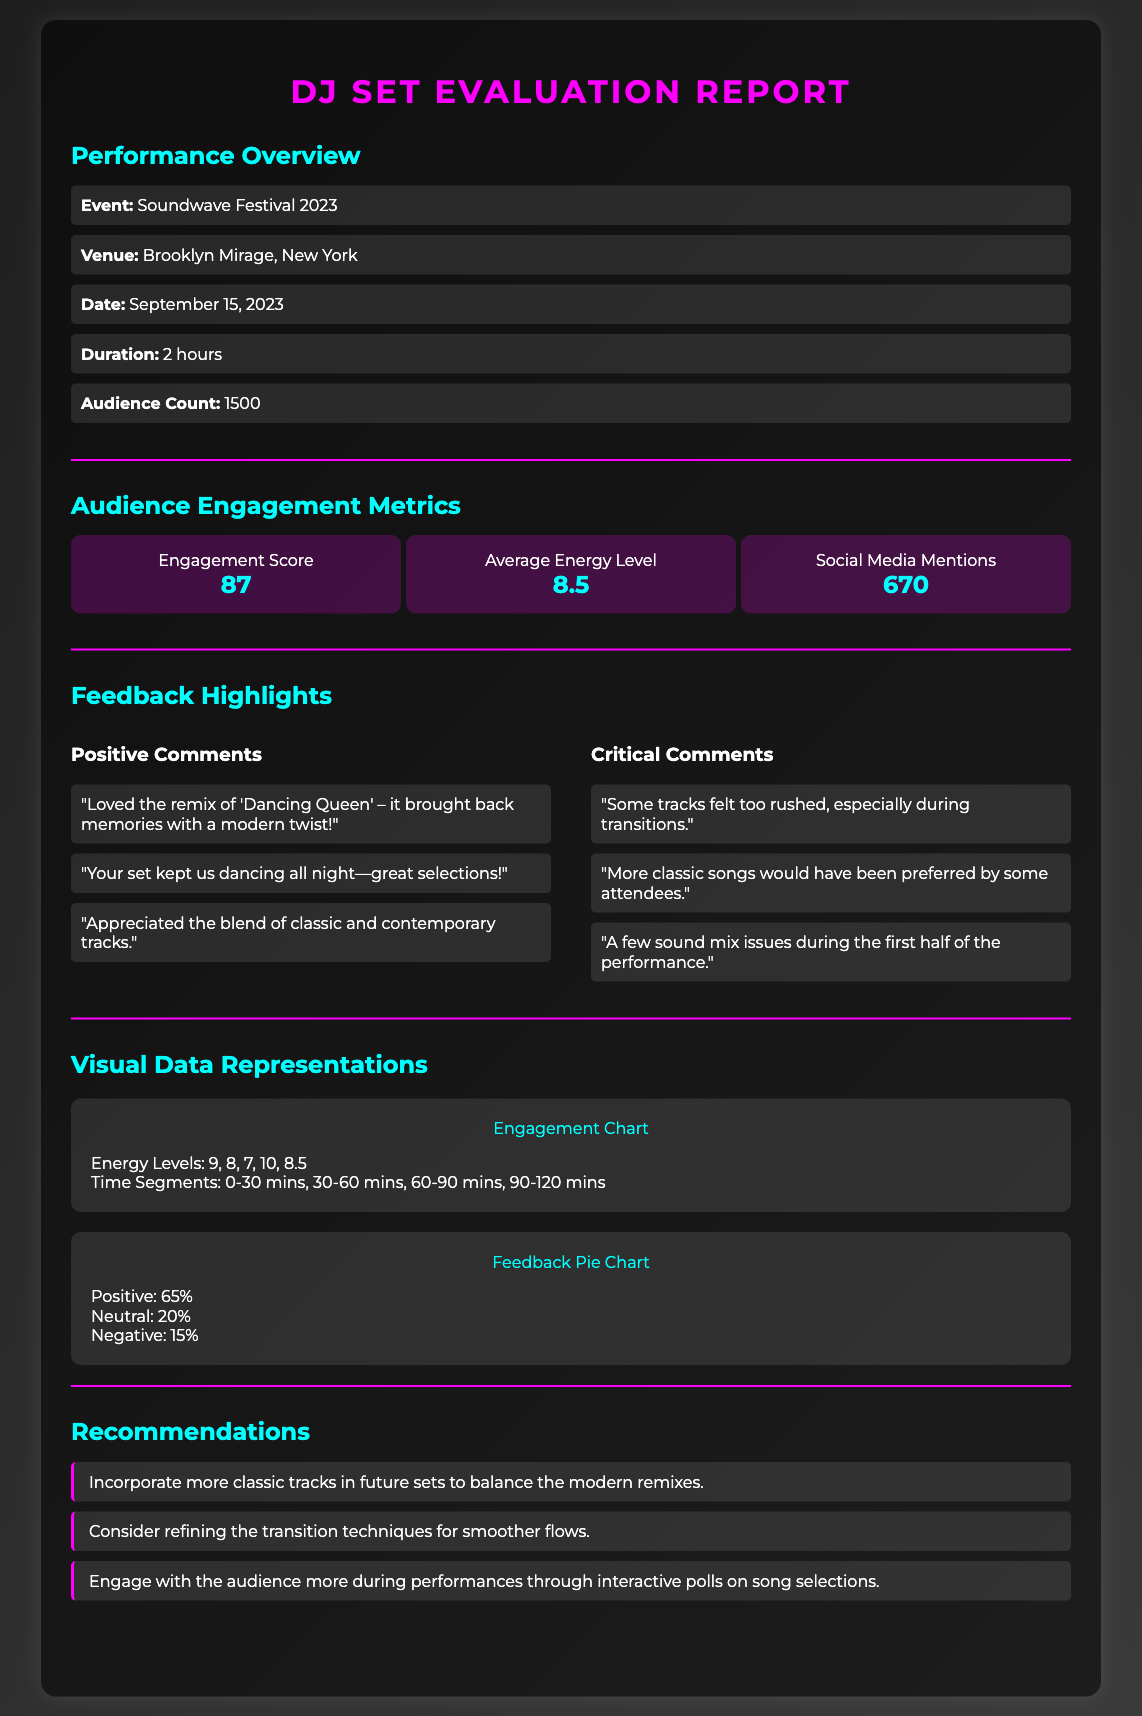What was the event name? The event name is stated at the beginning of the document, specifically in the Performance Overview section.
Answer: Soundwave Festival 2023 How many audience members attended? The audience count is provided in the Performance Overview section.
Answer: 1500 What was the Engagement Score? The Engagement Score is listed under Audience Engagement Metrics.
Answer: 87 What percentage of feedback was positive? The positive feedback percentage is mentioned in the Feedback Pie Chart visual representation.
Answer: 65% What was one critical comment received? The critical comments are provided in the Feedback Highlights section, specifically in a list format.
Answer: Some tracks felt too rushed, especially during transitions Which venue hosted the performance? The venue is indicated in the Performance Overview section of the document.
Answer: Brooklyn Mirage, New York What is one recommendation for future sets? Recommendations are listed at the end of the document; one is the incorporation of more classic tracks.
Answer: Incorporate more classic tracks in future sets to balance the modern remixes What was the average energy level? The average energy level is shown under Audience Engagement Metrics.
Answer: 8.5 What percentage of feedback was negative? The negative feedback percentage is included in the Feedback Pie Chart visual representation.
Answer: 15% 